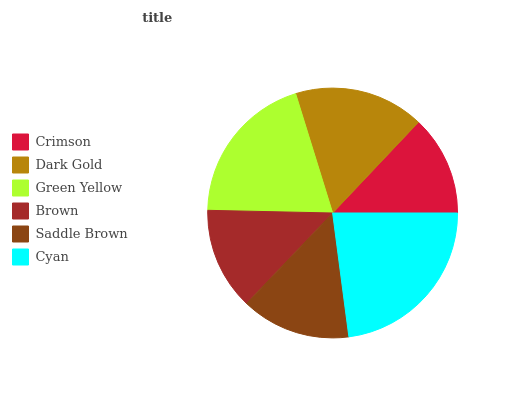Is Crimson the minimum?
Answer yes or no. Yes. Is Cyan the maximum?
Answer yes or no. Yes. Is Dark Gold the minimum?
Answer yes or no. No. Is Dark Gold the maximum?
Answer yes or no. No. Is Dark Gold greater than Crimson?
Answer yes or no. Yes. Is Crimson less than Dark Gold?
Answer yes or no. Yes. Is Crimson greater than Dark Gold?
Answer yes or no. No. Is Dark Gold less than Crimson?
Answer yes or no. No. Is Dark Gold the high median?
Answer yes or no. Yes. Is Saddle Brown the low median?
Answer yes or no. Yes. Is Saddle Brown the high median?
Answer yes or no. No. Is Crimson the low median?
Answer yes or no. No. 